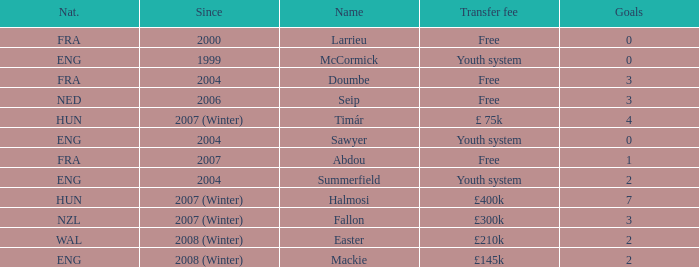What is the nationality of the player with a transfer fee of £400k? HUN. 